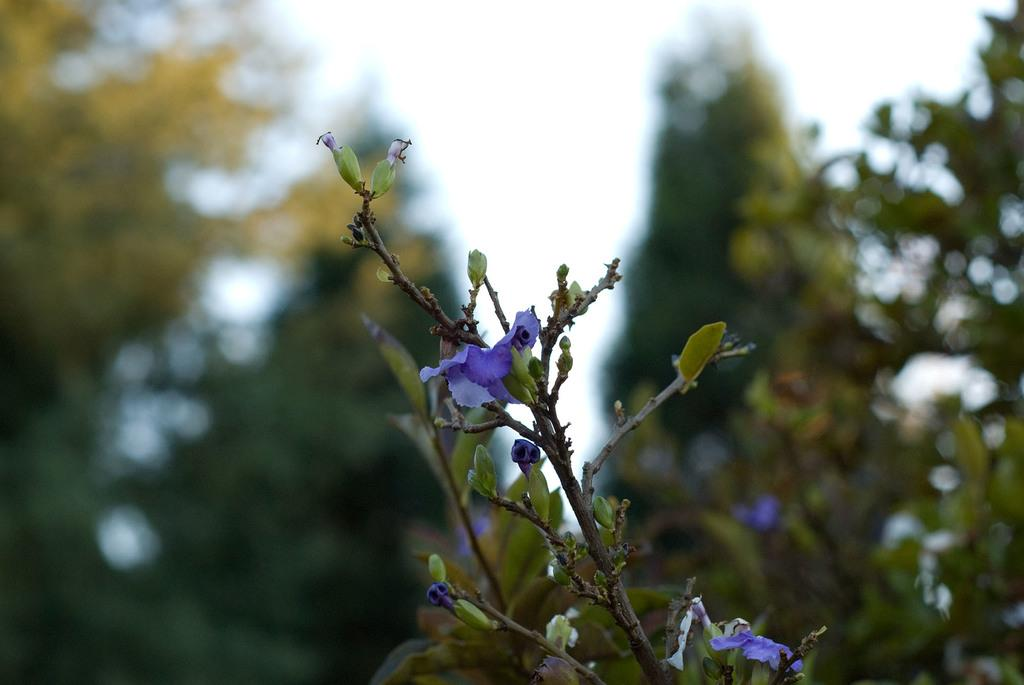What is located in the foreground of the image? There is a plant and flowers in the foreground of the image. What can be seen in the background of the image? There are trees and the sky visible in the background of the image. How many cats are sleeping on the flowers in the image? There are no cats present in the image, and the flowers are not depicted as a place for sleeping. 